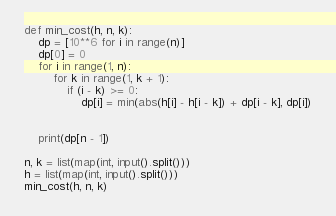<code> <loc_0><loc_0><loc_500><loc_500><_Python_>def min_cost(h, n, k):
    dp = [10**6 for i in range(n)]
    dp[0] = 0
    for i in range(1, n):
        for k in range(1, k + 1):
            if (i - k) >= 0:
                dp[i] = min(abs(h[i] - h[i - k]) + dp[i - k], dp[i])


    print(dp[n - 1])

n, k = list(map(int, input().split()))
h = list(map(int, input().split()))
min_cost(h, n, k)

</code> 